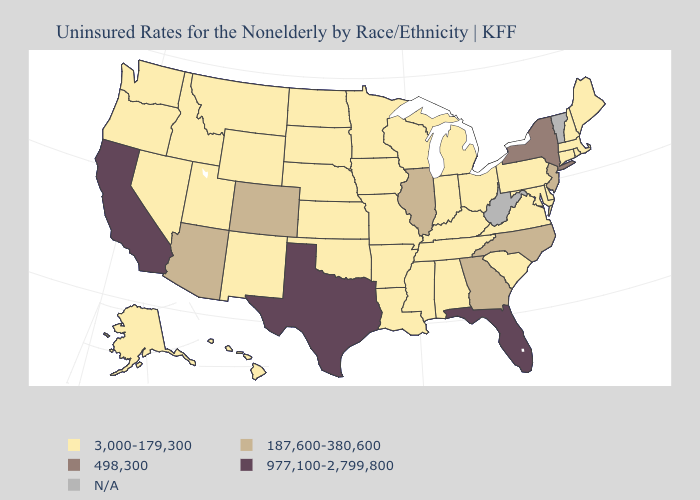Does New Mexico have the highest value in the West?
Keep it brief. No. Name the states that have a value in the range 498,300?
Short answer required. New York. Name the states that have a value in the range 977,100-2,799,800?
Short answer required. California, Florida, Texas. Is the legend a continuous bar?
Write a very short answer. No. What is the lowest value in the USA?
Be succinct. 3,000-179,300. Does Utah have the lowest value in the West?
Write a very short answer. Yes. Which states have the lowest value in the West?
Answer briefly. Alaska, Hawaii, Idaho, Montana, Nevada, New Mexico, Oregon, Utah, Washington, Wyoming. What is the value of Massachusetts?
Short answer required. 3,000-179,300. Does New York have the lowest value in the Northeast?
Give a very brief answer. No. What is the lowest value in states that border Pennsylvania?
Concise answer only. 3,000-179,300. What is the lowest value in the USA?
Be succinct. 3,000-179,300. Which states hav the highest value in the Northeast?
Answer briefly. New York. Which states have the lowest value in the South?
Write a very short answer. Alabama, Arkansas, Delaware, Kentucky, Louisiana, Maryland, Mississippi, Oklahoma, South Carolina, Tennessee, Virginia. 